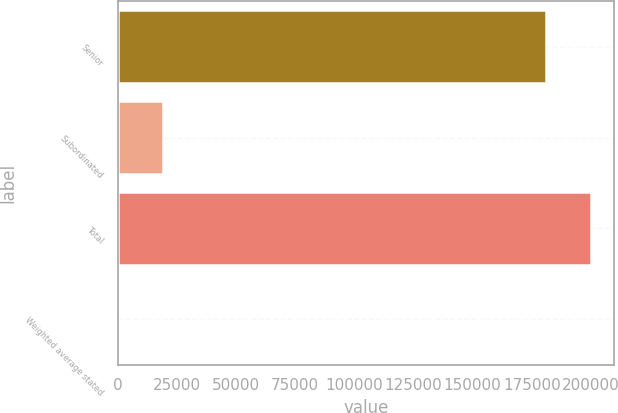<chart> <loc_0><loc_0><loc_500><loc_500><bar_chart><fcel>Senior<fcel>Subordinated<fcel>Total<fcel>Weighted average stated<nl><fcel>180835<fcel>19112.2<fcel>199941<fcel>6.6<nl></chart> 